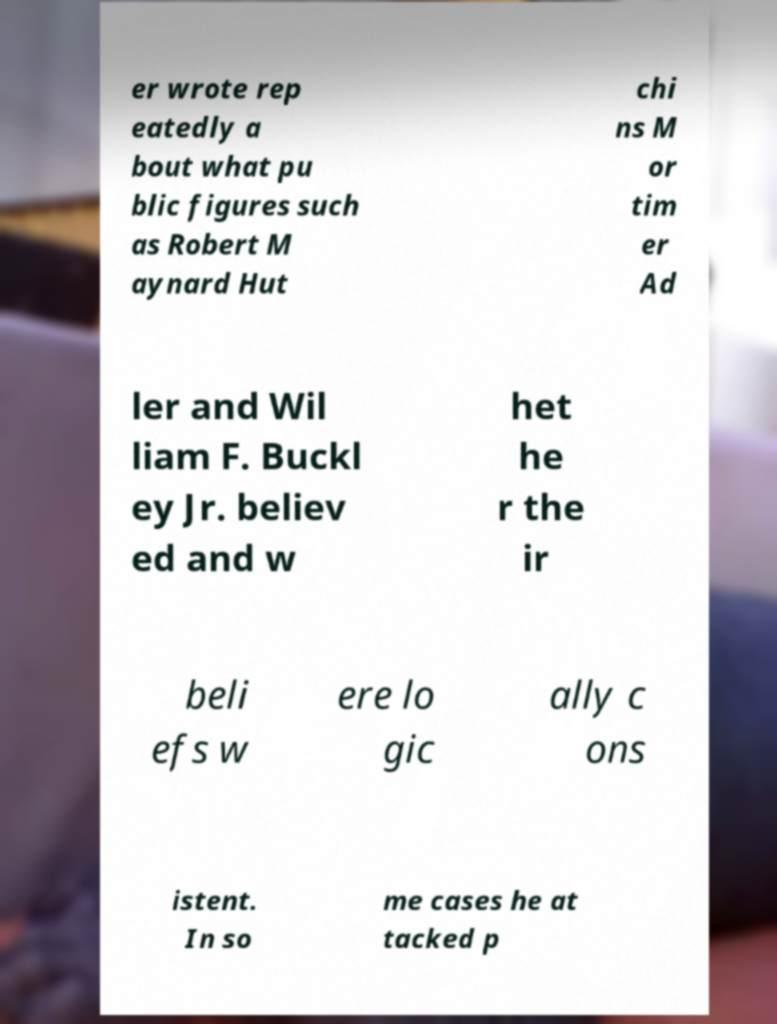What messages or text are displayed in this image? I need them in a readable, typed format. er wrote rep eatedly a bout what pu blic figures such as Robert M aynard Hut chi ns M or tim er Ad ler and Wil liam F. Buckl ey Jr. believ ed and w het he r the ir beli efs w ere lo gic ally c ons istent. In so me cases he at tacked p 